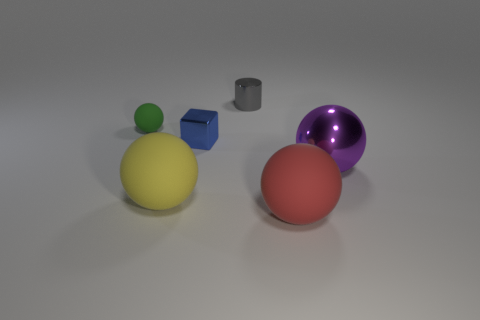Is there any other thing that is the same shape as the small gray thing?
Your answer should be very brief. No. Is the number of gray objects left of the tiny block less than the number of yellow rubber cylinders?
Give a very brief answer. No. What is the color of the cube that is in front of the small matte ball?
Give a very brief answer. Blue. Is there another object of the same shape as the large shiny thing?
Your response must be concise. Yes. What number of yellow things have the same shape as the tiny green object?
Give a very brief answer. 1. Do the block and the shiny ball have the same color?
Your response must be concise. No. Is the number of large yellow rubber objects less than the number of cyan cylinders?
Offer a terse response. No. What is the material of the ball that is behind the big purple sphere?
Offer a very short reply. Rubber. There is a purple sphere that is the same size as the yellow rubber sphere; what is it made of?
Offer a very short reply. Metal. What is the material of the small cube that is in front of the tiny object behind the rubber sphere behind the tiny blue metal object?
Make the answer very short. Metal. 